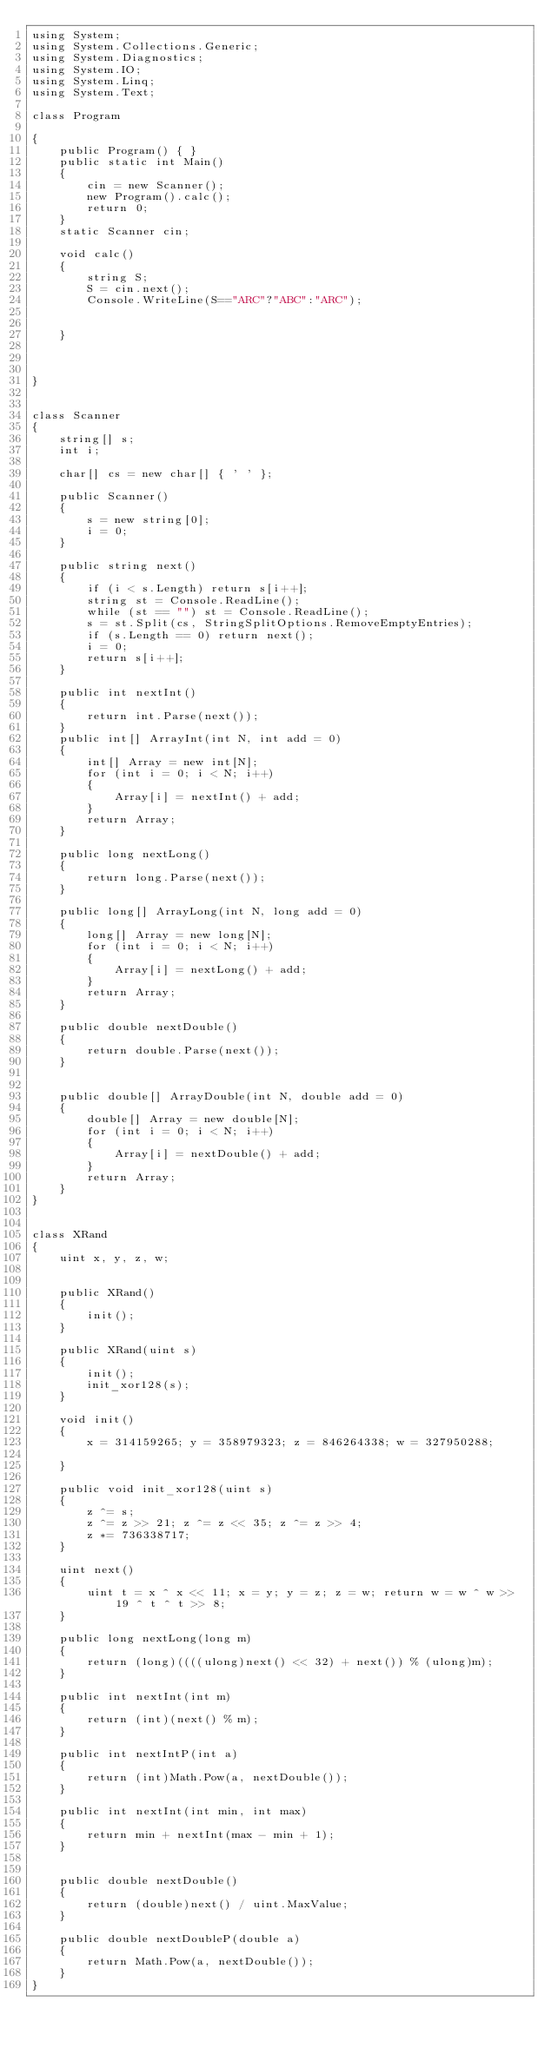<code> <loc_0><loc_0><loc_500><loc_500><_C#_>using System;
using System.Collections.Generic;
using System.Diagnostics;
using System.IO;
using System.Linq;
using System.Text;

class Program

{
    public Program() { }
    public static int Main()
    {
        cin = new Scanner();
        new Program().calc();
        return 0;
    }
    static Scanner cin;

    void calc()
    {
        string S;
        S = cin.next();
        Console.WriteLine(S=="ARC"?"ABC":"ARC");


    }



}


class Scanner
{
    string[] s;
    int i;

    char[] cs = new char[] { ' ' };

    public Scanner()
    {
        s = new string[0];
        i = 0;
    }

    public string next()
    {
        if (i < s.Length) return s[i++];
        string st = Console.ReadLine();
        while (st == "") st = Console.ReadLine();
        s = st.Split(cs, StringSplitOptions.RemoveEmptyEntries);
        if (s.Length == 0) return next();
        i = 0;
        return s[i++];
    }

    public int nextInt()
    {
        return int.Parse(next());
    }
    public int[] ArrayInt(int N, int add = 0)
    {
        int[] Array = new int[N];
        for (int i = 0; i < N; i++)
        {
            Array[i] = nextInt() + add;
        }
        return Array;
    }

    public long nextLong()
    {
        return long.Parse(next());
    }

    public long[] ArrayLong(int N, long add = 0)
    {
        long[] Array = new long[N];
        for (int i = 0; i < N; i++)
        {
            Array[i] = nextLong() + add;
        }
        return Array;
    }

    public double nextDouble()
    {
        return double.Parse(next());
    }


    public double[] ArrayDouble(int N, double add = 0)
    {
        double[] Array = new double[N];
        for (int i = 0; i < N; i++)
        {
            Array[i] = nextDouble() + add;
        }
        return Array;
    }
}


class XRand
{
    uint x, y, z, w;


    public XRand()
    {
        init();
    }

    public XRand(uint s)
    {
        init();
        init_xor128(s);
    }

    void init()
    {
        x = 314159265; y = 358979323; z = 846264338; w = 327950288;

    }

    public void init_xor128(uint s)
    {
        z ^= s;
        z ^= z >> 21; z ^= z << 35; z ^= z >> 4;
        z *= 736338717;
    }

    uint next()
    {
        uint t = x ^ x << 11; x = y; y = z; z = w; return w = w ^ w >> 19 ^ t ^ t >> 8;
    }

    public long nextLong(long m)
    {
        return (long)((((ulong)next() << 32) + next()) % (ulong)m);
    }

    public int nextInt(int m)
    {
        return (int)(next() % m);
    }

    public int nextIntP(int a)
    {
        return (int)Math.Pow(a, nextDouble());
    }

    public int nextInt(int min, int max)
    {
        return min + nextInt(max - min + 1);
    }


    public double nextDouble()
    {
        return (double)next() / uint.MaxValue;
    }

    public double nextDoubleP(double a)
    {
        return Math.Pow(a, nextDouble());
    }
}</code> 